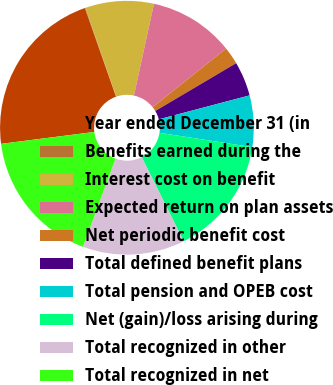<chart> <loc_0><loc_0><loc_500><loc_500><pie_chart><fcel>Year ended December 31 (in<fcel>Benefits earned during the<fcel>Interest cost on benefit<fcel>Expected return on plan assets<fcel>Net periodic benefit cost<fcel>Total defined benefit plans<fcel>Total pension and OPEB cost<fcel>Net (gain)/loss arising during<fcel>Total recognized in other<fcel>Total recognized in net<nl><fcel>21.65%<fcel>0.08%<fcel>8.71%<fcel>10.86%<fcel>2.23%<fcel>4.39%<fcel>6.55%<fcel>15.18%<fcel>13.02%<fcel>17.34%<nl></chart> 